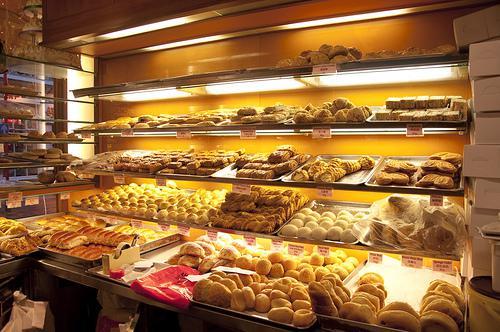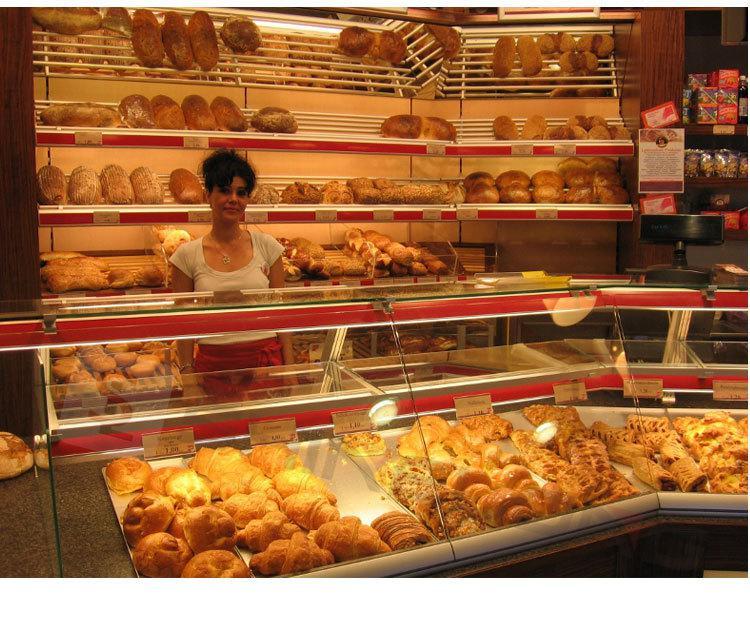The first image is the image on the left, the second image is the image on the right. Given the left and right images, does the statement "One female worker with a white top and no hat is behind a glass display case that turns a corner, in one image." hold true? Answer yes or no. Yes. The first image is the image on the left, the second image is the image on the right. Analyze the images presented: Is the assertion "A sign announces the name of the bakery in the image on the right." valid? Answer yes or no. No. 